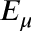<formula> <loc_0><loc_0><loc_500><loc_500>E _ { \mu }</formula> 